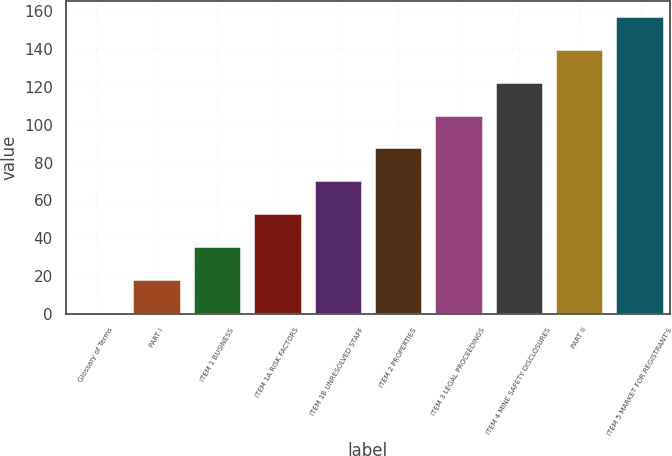Convert chart. <chart><loc_0><loc_0><loc_500><loc_500><bar_chart><fcel>Glossary of Terms<fcel>PART I<fcel>ITEM 1 BUSINESS<fcel>ITEM 1A RISK FACTORS<fcel>ITEM 1B UNRESOLVED STAFF<fcel>ITEM 2 PROPERTIES<fcel>ITEM 3 LEGAL PROCEEDINGS<fcel>ITEM 4 MINE SAFETY DISCLOSURES<fcel>PART II<fcel>ITEM 5 MARKET FOR REGISTRANT'S<nl><fcel>1<fcel>18.4<fcel>35.8<fcel>53.2<fcel>70.6<fcel>88<fcel>105.4<fcel>122.8<fcel>140.2<fcel>157.6<nl></chart> 